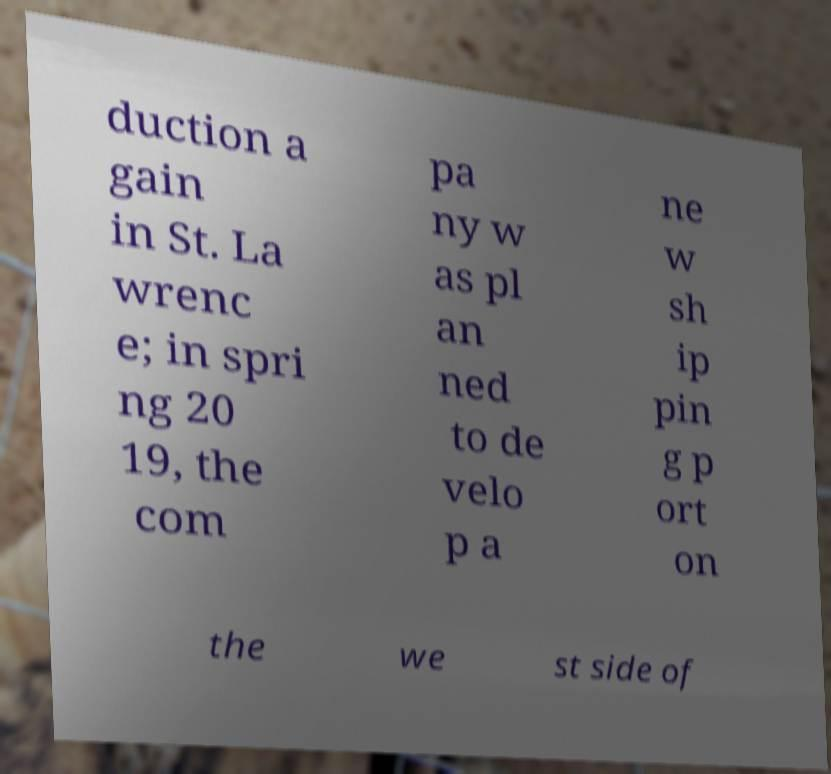There's text embedded in this image that I need extracted. Can you transcribe it verbatim? duction a gain in St. La wrenc e; in spri ng 20 19, the com pa ny w as pl an ned to de velo p a ne w sh ip pin g p ort on the we st side of 